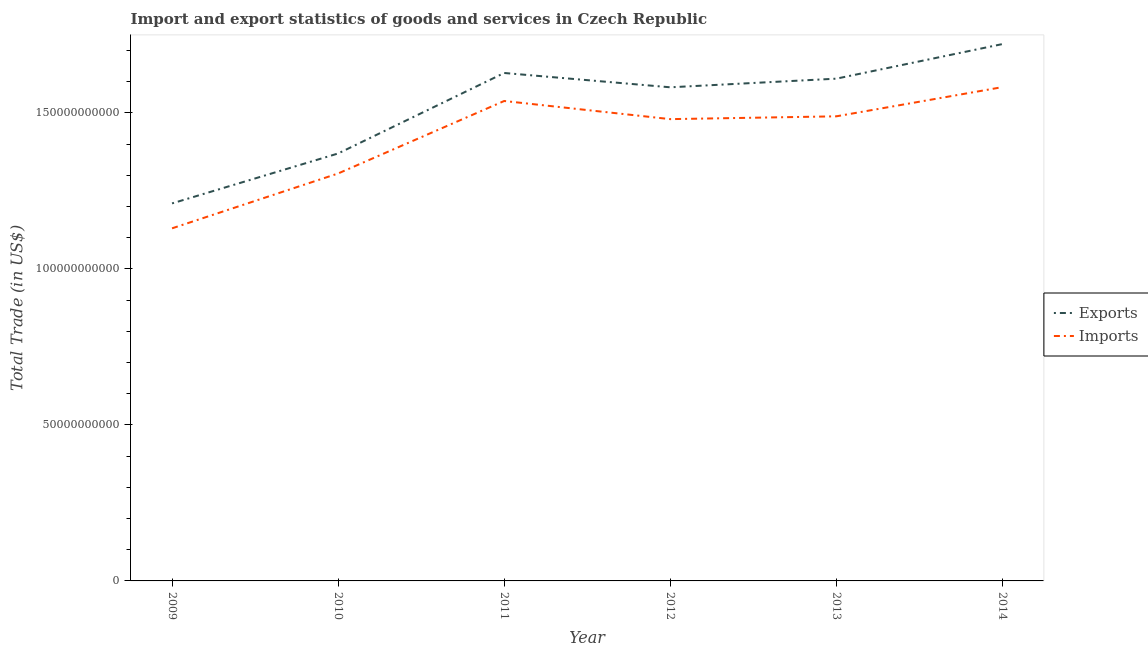How many different coloured lines are there?
Give a very brief answer. 2. Does the line corresponding to imports of goods and services intersect with the line corresponding to export of goods and services?
Give a very brief answer. No. What is the export of goods and services in 2009?
Provide a short and direct response. 1.21e+11. Across all years, what is the maximum export of goods and services?
Give a very brief answer. 1.72e+11. Across all years, what is the minimum imports of goods and services?
Your answer should be very brief. 1.13e+11. In which year was the imports of goods and services maximum?
Your answer should be compact. 2014. In which year was the export of goods and services minimum?
Provide a succinct answer. 2009. What is the total export of goods and services in the graph?
Your response must be concise. 9.12e+11. What is the difference between the export of goods and services in 2011 and that in 2014?
Your response must be concise. -9.26e+09. What is the difference between the export of goods and services in 2009 and the imports of goods and services in 2013?
Make the answer very short. -2.79e+1. What is the average imports of goods and services per year?
Your answer should be compact. 1.42e+11. In the year 2010, what is the difference between the export of goods and services and imports of goods and services?
Ensure brevity in your answer.  6.42e+09. What is the ratio of the export of goods and services in 2009 to that in 2014?
Offer a very short reply. 0.7. Is the difference between the imports of goods and services in 2010 and 2012 greater than the difference between the export of goods and services in 2010 and 2012?
Ensure brevity in your answer.  Yes. What is the difference between the highest and the second highest export of goods and services?
Provide a succinct answer. 9.26e+09. What is the difference between the highest and the lowest export of goods and services?
Offer a terse response. 5.11e+1. Is the export of goods and services strictly greater than the imports of goods and services over the years?
Keep it short and to the point. Yes. How many lines are there?
Give a very brief answer. 2. Are the values on the major ticks of Y-axis written in scientific E-notation?
Your answer should be very brief. No. Does the graph contain any zero values?
Ensure brevity in your answer.  No. Does the graph contain grids?
Keep it short and to the point. No. What is the title of the graph?
Ensure brevity in your answer.  Import and export statistics of goods and services in Czech Republic. Does "Quality of trade" appear as one of the legend labels in the graph?
Provide a succinct answer. No. What is the label or title of the X-axis?
Your answer should be compact. Year. What is the label or title of the Y-axis?
Offer a very short reply. Total Trade (in US$). What is the Total Trade (in US$) of Exports in 2009?
Your answer should be very brief. 1.21e+11. What is the Total Trade (in US$) in Imports in 2009?
Ensure brevity in your answer.  1.13e+11. What is the Total Trade (in US$) in Exports in 2010?
Provide a short and direct response. 1.37e+11. What is the Total Trade (in US$) in Imports in 2010?
Your response must be concise. 1.31e+11. What is the Total Trade (in US$) in Exports in 2011?
Your answer should be very brief. 1.63e+11. What is the Total Trade (in US$) in Imports in 2011?
Your answer should be very brief. 1.54e+11. What is the Total Trade (in US$) in Exports in 2012?
Give a very brief answer. 1.58e+11. What is the Total Trade (in US$) in Imports in 2012?
Provide a short and direct response. 1.48e+11. What is the Total Trade (in US$) of Exports in 2013?
Offer a very short reply. 1.61e+11. What is the Total Trade (in US$) in Imports in 2013?
Your answer should be very brief. 1.49e+11. What is the Total Trade (in US$) in Exports in 2014?
Ensure brevity in your answer.  1.72e+11. What is the Total Trade (in US$) of Imports in 2014?
Keep it short and to the point. 1.58e+11. Across all years, what is the maximum Total Trade (in US$) of Exports?
Make the answer very short. 1.72e+11. Across all years, what is the maximum Total Trade (in US$) in Imports?
Make the answer very short. 1.58e+11. Across all years, what is the minimum Total Trade (in US$) of Exports?
Offer a terse response. 1.21e+11. Across all years, what is the minimum Total Trade (in US$) of Imports?
Your response must be concise. 1.13e+11. What is the total Total Trade (in US$) in Exports in the graph?
Ensure brevity in your answer.  9.12e+11. What is the total Total Trade (in US$) in Imports in the graph?
Provide a succinct answer. 8.53e+11. What is the difference between the Total Trade (in US$) of Exports in 2009 and that in 2010?
Your answer should be compact. -1.60e+1. What is the difference between the Total Trade (in US$) in Imports in 2009 and that in 2010?
Give a very brief answer. -1.76e+1. What is the difference between the Total Trade (in US$) of Exports in 2009 and that in 2011?
Your response must be concise. -4.18e+1. What is the difference between the Total Trade (in US$) in Imports in 2009 and that in 2011?
Offer a very short reply. -4.08e+1. What is the difference between the Total Trade (in US$) in Exports in 2009 and that in 2012?
Your answer should be compact. -3.72e+1. What is the difference between the Total Trade (in US$) of Imports in 2009 and that in 2012?
Provide a succinct answer. -3.50e+1. What is the difference between the Total Trade (in US$) in Exports in 2009 and that in 2013?
Offer a very short reply. -4.00e+1. What is the difference between the Total Trade (in US$) in Imports in 2009 and that in 2013?
Make the answer very short. -3.59e+1. What is the difference between the Total Trade (in US$) in Exports in 2009 and that in 2014?
Your answer should be very brief. -5.11e+1. What is the difference between the Total Trade (in US$) in Imports in 2009 and that in 2014?
Provide a succinct answer. -4.53e+1. What is the difference between the Total Trade (in US$) of Exports in 2010 and that in 2011?
Your response must be concise. -2.58e+1. What is the difference between the Total Trade (in US$) of Imports in 2010 and that in 2011?
Your answer should be compact. -2.32e+1. What is the difference between the Total Trade (in US$) of Exports in 2010 and that in 2012?
Offer a terse response. -2.12e+1. What is the difference between the Total Trade (in US$) in Imports in 2010 and that in 2012?
Provide a short and direct response. -1.74e+1. What is the difference between the Total Trade (in US$) of Exports in 2010 and that in 2013?
Your response must be concise. -2.40e+1. What is the difference between the Total Trade (in US$) in Imports in 2010 and that in 2013?
Provide a succinct answer. -1.83e+1. What is the difference between the Total Trade (in US$) of Exports in 2010 and that in 2014?
Give a very brief answer. -3.51e+1. What is the difference between the Total Trade (in US$) of Imports in 2010 and that in 2014?
Give a very brief answer. -2.77e+1. What is the difference between the Total Trade (in US$) in Exports in 2011 and that in 2012?
Give a very brief answer. 4.59e+09. What is the difference between the Total Trade (in US$) of Imports in 2011 and that in 2012?
Provide a short and direct response. 5.82e+09. What is the difference between the Total Trade (in US$) in Exports in 2011 and that in 2013?
Your answer should be compact. 1.82e+09. What is the difference between the Total Trade (in US$) in Imports in 2011 and that in 2013?
Your answer should be very brief. 4.91e+09. What is the difference between the Total Trade (in US$) in Exports in 2011 and that in 2014?
Give a very brief answer. -9.26e+09. What is the difference between the Total Trade (in US$) of Imports in 2011 and that in 2014?
Ensure brevity in your answer.  -4.44e+09. What is the difference between the Total Trade (in US$) in Exports in 2012 and that in 2013?
Your response must be concise. -2.77e+09. What is the difference between the Total Trade (in US$) of Imports in 2012 and that in 2013?
Provide a short and direct response. -9.01e+08. What is the difference between the Total Trade (in US$) of Exports in 2012 and that in 2014?
Your answer should be compact. -1.38e+1. What is the difference between the Total Trade (in US$) of Imports in 2012 and that in 2014?
Your answer should be very brief. -1.03e+1. What is the difference between the Total Trade (in US$) in Exports in 2013 and that in 2014?
Provide a succinct answer. -1.11e+1. What is the difference between the Total Trade (in US$) of Imports in 2013 and that in 2014?
Keep it short and to the point. -9.36e+09. What is the difference between the Total Trade (in US$) of Exports in 2009 and the Total Trade (in US$) of Imports in 2010?
Your response must be concise. -9.59e+09. What is the difference between the Total Trade (in US$) of Exports in 2009 and the Total Trade (in US$) of Imports in 2011?
Make the answer very short. -3.28e+1. What is the difference between the Total Trade (in US$) of Exports in 2009 and the Total Trade (in US$) of Imports in 2012?
Keep it short and to the point. -2.70e+1. What is the difference between the Total Trade (in US$) in Exports in 2009 and the Total Trade (in US$) in Imports in 2013?
Provide a succinct answer. -2.79e+1. What is the difference between the Total Trade (in US$) in Exports in 2009 and the Total Trade (in US$) in Imports in 2014?
Make the answer very short. -3.73e+1. What is the difference between the Total Trade (in US$) in Exports in 2010 and the Total Trade (in US$) in Imports in 2011?
Give a very brief answer. -1.68e+1. What is the difference between the Total Trade (in US$) in Exports in 2010 and the Total Trade (in US$) in Imports in 2012?
Keep it short and to the point. -1.10e+1. What is the difference between the Total Trade (in US$) of Exports in 2010 and the Total Trade (in US$) of Imports in 2013?
Your answer should be very brief. -1.19e+1. What is the difference between the Total Trade (in US$) in Exports in 2010 and the Total Trade (in US$) in Imports in 2014?
Your answer should be compact. -2.13e+1. What is the difference between the Total Trade (in US$) of Exports in 2011 and the Total Trade (in US$) of Imports in 2012?
Make the answer very short. 1.48e+1. What is the difference between the Total Trade (in US$) of Exports in 2011 and the Total Trade (in US$) of Imports in 2013?
Offer a very short reply. 1.39e+1. What is the difference between the Total Trade (in US$) of Exports in 2011 and the Total Trade (in US$) of Imports in 2014?
Your answer should be very brief. 4.53e+09. What is the difference between the Total Trade (in US$) in Exports in 2012 and the Total Trade (in US$) in Imports in 2013?
Provide a succinct answer. 9.30e+09. What is the difference between the Total Trade (in US$) in Exports in 2012 and the Total Trade (in US$) in Imports in 2014?
Provide a short and direct response. -5.51e+07. What is the difference between the Total Trade (in US$) of Exports in 2013 and the Total Trade (in US$) of Imports in 2014?
Keep it short and to the point. 2.71e+09. What is the average Total Trade (in US$) in Exports per year?
Provide a short and direct response. 1.52e+11. What is the average Total Trade (in US$) of Imports per year?
Offer a terse response. 1.42e+11. In the year 2009, what is the difference between the Total Trade (in US$) of Exports and Total Trade (in US$) of Imports?
Make the answer very short. 7.99e+09. In the year 2010, what is the difference between the Total Trade (in US$) of Exports and Total Trade (in US$) of Imports?
Make the answer very short. 6.42e+09. In the year 2011, what is the difference between the Total Trade (in US$) of Exports and Total Trade (in US$) of Imports?
Provide a short and direct response. 8.98e+09. In the year 2012, what is the difference between the Total Trade (in US$) in Exports and Total Trade (in US$) in Imports?
Offer a very short reply. 1.02e+1. In the year 2013, what is the difference between the Total Trade (in US$) of Exports and Total Trade (in US$) of Imports?
Your answer should be compact. 1.21e+1. In the year 2014, what is the difference between the Total Trade (in US$) of Exports and Total Trade (in US$) of Imports?
Offer a terse response. 1.38e+1. What is the ratio of the Total Trade (in US$) in Exports in 2009 to that in 2010?
Your answer should be very brief. 0.88. What is the ratio of the Total Trade (in US$) of Imports in 2009 to that in 2010?
Your response must be concise. 0.87. What is the ratio of the Total Trade (in US$) in Exports in 2009 to that in 2011?
Provide a succinct answer. 0.74. What is the ratio of the Total Trade (in US$) in Imports in 2009 to that in 2011?
Ensure brevity in your answer.  0.73. What is the ratio of the Total Trade (in US$) of Exports in 2009 to that in 2012?
Your answer should be compact. 0.76. What is the ratio of the Total Trade (in US$) in Imports in 2009 to that in 2012?
Your answer should be very brief. 0.76. What is the ratio of the Total Trade (in US$) of Exports in 2009 to that in 2013?
Provide a succinct answer. 0.75. What is the ratio of the Total Trade (in US$) in Imports in 2009 to that in 2013?
Provide a short and direct response. 0.76. What is the ratio of the Total Trade (in US$) in Exports in 2009 to that in 2014?
Offer a very short reply. 0.7. What is the ratio of the Total Trade (in US$) of Imports in 2009 to that in 2014?
Your response must be concise. 0.71. What is the ratio of the Total Trade (in US$) in Exports in 2010 to that in 2011?
Give a very brief answer. 0.84. What is the ratio of the Total Trade (in US$) in Imports in 2010 to that in 2011?
Your answer should be very brief. 0.85. What is the ratio of the Total Trade (in US$) in Exports in 2010 to that in 2012?
Ensure brevity in your answer.  0.87. What is the ratio of the Total Trade (in US$) in Imports in 2010 to that in 2012?
Offer a very short reply. 0.88. What is the ratio of the Total Trade (in US$) of Exports in 2010 to that in 2013?
Your answer should be very brief. 0.85. What is the ratio of the Total Trade (in US$) in Imports in 2010 to that in 2013?
Keep it short and to the point. 0.88. What is the ratio of the Total Trade (in US$) in Exports in 2010 to that in 2014?
Your response must be concise. 0.8. What is the ratio of the Total Trade (in US$) in Imports in 2010 to that in 2014?
Keep it short and to the point. 0.83. What is the ratio of the Total Trade (in US$) in Exports in 2011 to that in 2012?
Your response must be concise. 1.03. What is the ratio of the Total Trade (in US$) of Imports in 2011 to that in 2012?
Keep it short and to the point. 1.04. What is the ratio of the Total Trade (in US$) of Exports in 2011 to that in 2013?
Give a very brief answer. 1.01. What is the ratio of the Total Trade (in US$) in Imports in 2011 to that in 2013?
Make the answer very short. 1.03. What is the ratio of the Total Trade (in US$) of Exports in 2011 to that in 2014?
Provide a short and direct response. 0.95. What is the ratio of the Total Trade (in US$) in Imports in 2011 to that in 2014?
Your response must be concise. 0.97. What is the ratio of the Total Trade (in US$) of Exports in 2012 to that in 2013?
Give a very brief answer. 0.98. What is the ratio of the Total Trade (in US$) of Imports in 2012 to that in 2013?
Give a very brief answer. 0.99. What is the ratio of the Total Trade (in US$) of Exports in 2012 to that in 2014?
Your response must be concise. 0.92. What is the ratio of the Total Trade (in US$) in Imports in 2012 to that in 2014?
Your answer should be very brief. 0.94. What is the ratio of the Total Trade (in US$) of Exports in 2013 to that in 2014?
Your response must be concise. 0.94. What is the ratio of the Total Trade (in US$) in Imports in 2013 to that in 2014?
Your answer should be compact. 0.94. What is the difference between the highest and the second highest Total Trade (in US$) in Exports?
Provide a succinct answer. 9.26e+09. What is the difference between the highest and the second highest Total Trade (in US$) in Imports?
Offer a very short reply. 4.44e+09. What is the difference between the highest and the lowest Total Trade (in US$) of Exports?
Provide a succinct answer. 5.11e+1. What is the difference between the highest and the lowest Total Trade (in US$) in Imports?
Ensure brevity in your answer.  4.53e+1. 